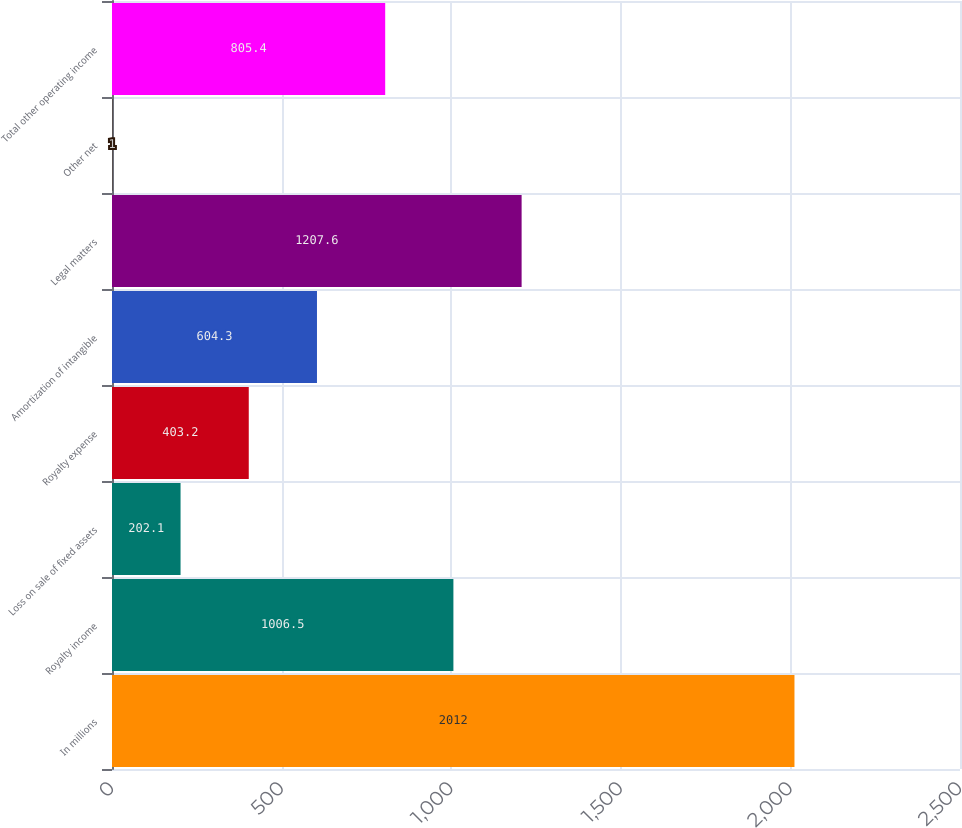Convert chart to OTSL. <chart><loc_0><loc_0><loc_500><loc_500><bar_chart><fcel>In millions<fcel>Royalty income<fcel>Loss on sale of fixed assets<fcel>Royalty expense<fcel>Amortization of intangible<fcel>Legal matters<fcel>Other net<fcel>Total other operating income<nl><fcel>2012<fcel>1006.5<fcel>202.1<fcel>403.2<fcel>604.3<fcel>1207.6<fcel>1<fcel>805.4<nl></chart> 